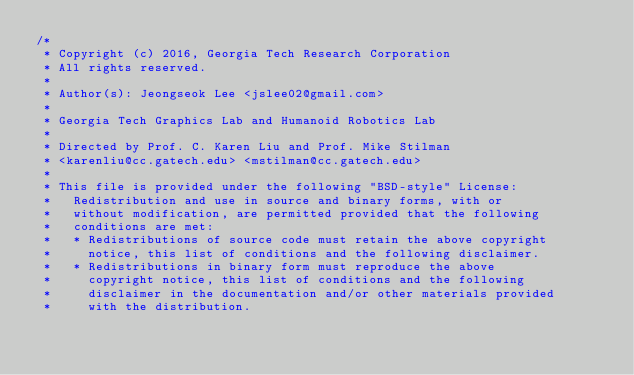<code> <loc_0><loc_0><loc_500><loc_500><_C++_>/*
 * Copyright (c) 2016, Georgia Tech Research Corporation
 * All rights reserved.
 *
 * Author(s): Jeongseok Lee <jslee02@gmail.com>
 *
 * Georgia Tech Graphics Lab and Humanoid Robotics Lab
 *
 * Directed by Prof. C. Karen Liu and Prof. Mike Stilman
 * <karenliu@cc.gatech.edu> <mstilman@cc.gatech.edu>
 *
 * This file is provided under the following "BSD-style" License:
 *   Redistribution and use in source and binary forms, with or
 *   without modification, are permitted provided that the following
 *   conditions are met:
 *   * Redistributions of source code must retain the above copyright
 *     notice, this list of conditions and the following disclaimer.
 *   * Redistributions in binary form must reproduce the above
 *     copyright notice, this list of conditions and the following
 *     disclaimer in the documentation and/or other materials provided
 *     with the distribution.</code> 